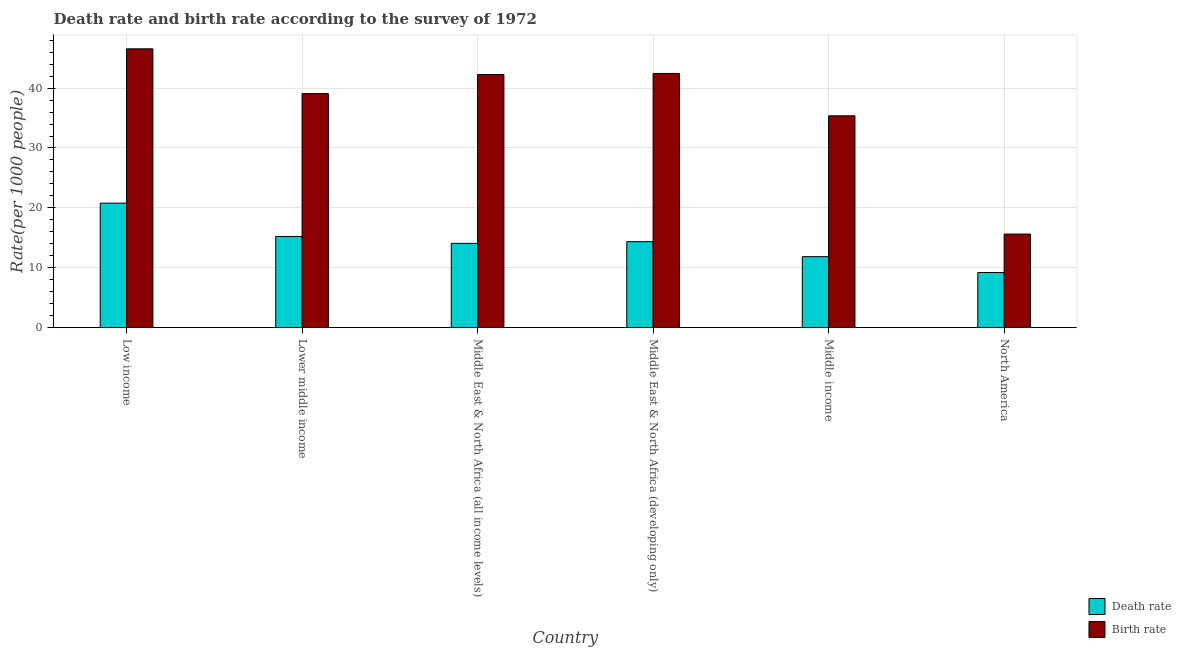How many different coloured bars are there?
Your response must be concise. 2. How many groups of bars are there?
Offer a terse response. 6. Are the number of bars per tick equal to the number of legend labels?
Ensure brevity in your answer.  Yes. How many bars are there on the 3rd tick from the left?
Ensure brevity in your answer.  2. What is the death rate in Lower middle income?
Your response must be concise. 15.23. Across all countries, what is the maximum birth rate?
Give a very brief answer. 46.56. Across all countries, what is the minimum birth rate?
Make the answer very short. 15.63. What is the total death rate in the graph?
Your response must be concise. 85.52. What is the difference between the birth rate in Middle East & North Africa (all income levels) and that in Middle East & North Africa (developing only)?
Provide a short and direct response. -0.18. What is the difference between the birth rate in North America and the death rate in Middle East & North Africa (all income levels)?
Provide a short and direct response. 1.55. What is the average birth rate per country?
Give a very brief answer. 36.89. What is the difference between the birth rate and death rate in Low income?
Keep it short and to the point. 25.76. In how many countries, is the death rate greater than 32 ?
Give a very brief answer. 0. What is the ratio of the death rate in Middle income to that in North America?
Provide a succinct answer. 1.29. Is the birth rate in Lower middle income less than that in North America?
Provide a short and direct response. No. What is the difference between the highest and the second highest death rate?
Provide a short and direct response. 5.57. What is the difference between the highest and the lowest birth rate?
Your answer should be very brief. 30.93. What does the 1st bar from the left in Middle income represents?
Ensure brevity in your answer.  Death rate. What does the 1st bar from the right in Middle East & North Africa (all income levels) represents?
Your response must be concise. Birth rate. How many countries are there in the graph?
Your response must be concise. 6. Are the values on the major ticks of Y-axis written in scientific E-notation?
Your answer should be very brief. No. Does the graph contain any zero values?
Provide a short and direct response. No. Does the graph contain grids?
Your answer should be compact. Yes. How many legend labels are there?
Provide a succinct answer. 2. How are the legend labels stacked?
Ensure brevity in your answer.  Vertical. What is the title of the graph?
Give a very brief answer. Death rate and birth rate according to the survey of 1972. Does "Ages 15-24" appear as one of the legend labels in the graph?
Provide a succinct answer. No. What is the label or title of the Y-axis?
Offer a very short reply. Rate(per 1000 people). What is the Rate(per 1000 people) in Death rate in Low income?
Give a very brief answer. 20.79. What is the Rate(per 1000 people) in Birth rate in Low income?
Ensure brevity in your answer.  46.56. What is the Rate(per 1000 people) in Death rate in Lower middle income?
Your response must be concise. 15.23. What is the Rate(per 1000 people) of Birth rate in Lower middle income?
Give a very brief answer. 39.08. What is the Rate(per 1000 people) of Death rate in Middle East & North Africa (all income levels)?
Make the answer very short. 14.08. What is the Rate(per 1000 people) of Birth rate in Middle East & North Africa (all income levels)?
Make the answer very short. 42.26. What is the Rate(per 1000 people) of Death rate in Middle East & North Africa (developing only)?
Your answer should be very brief. 14.36. What is the Rate(per 1000 people) of Birth rate in Middle East & North Africa (developing only)?
Ensure brevity in your answer.  42.44. What is the Rate(per 1000 people) in Death rate in Middle income?
Provide a succinct answer. 11.86. What is the Rate(per 1000 people) in Birth rate in Middle income?
Give a very brief answer. 35.37. What is the Rate(per 1000 people) of Death rate in North America?
Your answer should be very brief. 9.21. What is the Rate(per 1000 people) in Birth rate in North America?
Your answer should be very brief. 15.63. Across all countries, what is the maximum Rate(per 1000 people) of Death rate?
Offer a terse response. 20.79. Across all countries, what is the maximum Rate(per 1000 people) of Birth rate?
Offer a terse response. 46.56. Across all countries, what is the minimum Rate(per 1000 people) of Death rate?
Provide a short and direct response. 9.21. Across all countries, what is the minimum Rate(per 1000 people) in Birth rate?
Offer a terse response. 15.63. What is the total Rate(per 1000 people) of Death rate in the graph?
Keep it short and to the point. 85.52. What is the total Rate(per 1000 people) of Birth rate in the graph?
Offer a very short reply. 221.35. What is the difference between the Rate(per 1000 people) in Death rate in Low income and that in Lower middle income?
Provide a short and direct response. 5.57. What is the difference between the Rate(per 1000 people) in Birth rate in Low income and that in Lower middle income?
Offer a very short reply. 7.48. What is the difference between the Rate(per 1000 people) in Death rate in Low income and that in Middle East & North Africa (all income levels)?
Offer a very short reply. 6.72. What is the difference between the Rate(per 1000 people) in Birth rate in Low income and that in Middle East & North Africa (all income levels)?
Provide a succinct answer. 4.29. What is the difference between the Rate(per 1000 people) in Death rate in Low income and that in Middle East & North Africa (developing only)?
Offer a very short reply. 6.43. What is the difference between the Rate(per 1000 people) in Birth rate in Low income and that in Middle East & North Africa (developing only)?
Make the answer very short. 4.12. What is the difference between the Rate(per 1000 people) in Death rate in Low income and that in Middle income?
Keep it short and to the point. 8.94. What is the difference between the Rate(per 1000 people) in Birth rate in Low income and that in Middle income?
Make the answer very short. 11.18. What is the difference between the Rate(per 1000 people) in Death rate in Low income and that in North America?
Your answer should be very brief. 11.58. What is the difference between the Rate(per 1000 people) in Birth rate in Low income and that in North America?
Provide a short and direct response. 30.93. What is the difference between the Rate(per 1000 people) in Death rate in Lower middle income and that in Middle East & North Africa (all income levels)?
Provide a succinct answer. 1.15. What is the difference between the Rate(per 1000 people) in Birth rate in Lower middle income and that in Middle East & North Africa (all income levels)?
Offer a terse response. -3.18. What is the difference between the Rate(per 1000 people) of Death rate in Lower middle income and that in Middle East & North Africa (developing only)?
Give a very brief answer. 0.87. What is the difference between the Rate(per 1000 people) of Birth rate in Lower middle income and that in Middle East & North Africa (developing only)?
Keep it short and to the point. -3.36. What is the difference between the Rate(per 1000 people) in Death rate in Lower middle income and that in Middle income?
Your answer should be very brief. 3.37. What is the difference between the Rate(per 1000 people) of Birth rate in Lower middle income and that in Middle income?
Your response must be concise. 3.71. What is the difference between the Rate(per 1000 people) in Death rate in Lower middle income and that in North America?
Your answer should be very brief. 6.02. What is the difference between the Rate(per 1000 people) in Birth rate in Lower middle income and that in North America?
Provide a short and direct response. 23.45. What is the difference between the Rate(per 1000 people) of Death rate in Middle East & North Africa (all income levels) and that in Middle East & North Africa (developing only)?
Make the answer very short. -0.29. What is the difference between the Rate(per 1000 people) in Birth rate in Middle East & North Africa (all income levels) and that in Middle East & North Africa (developing only)?
Your answer should be compact. -0.18. What is the difference between the Rate(per 1000 people) of Death rate in Middle East & North Africa (all income levels) and that in Middle income?
Your response must be concise. 2.22. What is the difference between the Rate(per 1000 people) of Birth rate in Middle East & North Africa (all income levels) and that in Middle income?
Provide a short and direct response. 6.89. What is the difference between the Rate(per 1000 people) of Death rate in Middle East & North Africa (all income levels) and that in North America?
Keep it short and to the point. 4.87. What is the difference between the Rate(per 1000 people) in Birth rate in Middle East & North Africa (all income levels) and that in North America?
Your response must be concise. 26.63. What is the difference between the Rate(per 1000 people) in Death rate in Middle East & North Africa (developing only) and that in Middle income?
Your answer should be compact. 2.51. What is the difference between the Rate(per 1000 people) of Birth rate in Middle East & North Africa (developing only) and that in Middle income?
Provide a succinct answer. 7.07. What is the difference between the Rate(per 1000 people) of Death rate in Middle East & North Africa (developing only) and that in North America?
Give a very brief answer. 5.15. What is the difference between the Rate(per 1000 people) in Birth rate in Middle East & North Africa (developing only) and that in North America?
Make the answer very short. 26.81. What is the difference between the Rate(per 1000 people) in Death rate in Middle income and that in North America?
Your response must be concise. 2.65. What is the difference between the Rate(per 1000 people) in Birth rate in Middle income and that in North America?
Your response must be concise. 19.74. What is the difference between the Rate(per 1000 people) of Death rate in Low income and the Rate(per 1000 people) of Birth rate in Lower middle income?
Your response must be concise. -18.29. What is the difference between the Rate(per 1000 people) of Death rate in Low income and the Rate(per 1000 people) of Birth rate in Middle East & North Africa (all income levels)?
Offer a terse response. -21.47. What is the difference between the Rate(per 1000 people) in Death rate in Low income and the Rate(per 1000 people) in Birth rate in Middle East & North Africa (developing only)?
Ensure brevity in your answer.  -21.65. What is the difference between the Rate(per 1000 people) of Death rate in Low income and the Rate(per 1000 people) of Birth rate in Middle income?
Your answer should be compact. -14.58. What is the difference between the Rate(per 1000 people) in Death rate in Low income and the Rate(per 1000 people) in Birth rate in North America?
Give a very brief answer. 5.17. What is the difference between the Rate(per 1000 people) in Death rate in Lower middle income and the Rate(per 1000 people) in Birth rate in Middle East & North Africa (all income levels)?
Keep it short and to the point. -27.04. What is the difference between the Rate(per 1000 people) of Death rate in Lower middle income and the Rate(per 1000 people) of Birth rate in Middle East & North Africa (developing only)?
Your answer should be compact. -27.22. What is the difference between the Rate(per 1000 people) of Death rate in Lower middle income and the Rate(per 1000 people) of Birth rate in Middle income?
Keep it short and to the point. -20.15. What is the difference between the Rate(per 1000 people) of Death rate in Lower middle income and the Rate(per 1000 people) of Birth rate in North America?
Provide a short and direct response. -0.4. What is the difference between the Rate(per 1000 people) in Death rate in Middle East & North Africa (all income levels) and the Rate(per 1000 people) in Birth rate in Middle East & North Africa (developing only)?
Your answer should be very brief. -28.37. What is the difference between the Rate(per 1000 people) of Death rate in Middle East & North Africa (all income levels) and the Rate(per 1000 people) of Birth rate in Middle income?
Offer a terse response. -21.3. What is the difference between the Rate(per 1000 people) in Death rate in Middle East & North Africa (all income levels) and the Rate(per 1000 people) in Birth rate in North America?
Your response must be concise. -1.55. What is the difference between the Rate(per 1000 people) in Death rate in Middle East & North Africa (developing only) and the Rate(per 1000 people) in Birth rate in Middle income?
Provide a succinct answer. -21.01. What is the difference between the Rate(per 1000 people) of Death rate in Middle East & North Africa (developing only) and the Rate(per 1000 people) of Birth rate in North America?
Keep it short and to the point. -1.27. What is the difference between the Rate(per 1000 people) of Death rate in Middle income and the Rate(per 1000 people) of Birth rate in North America?
Keep it short and to the point. -3.77. What is the average Rate(per 1000 people) of Death rate per country?
Keep it short and to the point. 14.25. What is the average Rate(per 1000 people) in Birth rate per country?
Ensure brevity in your answer.  36.89. What is the difference between the Rate(per 1000 people) of Death rate and Rate(per 1000 people) of Birth rate in Low income?
Provide a succinct answer. -25.76. What is the difference between the Rate(per 1000 people) of Death rate and Rate(per 1000 people) of Birth rate in Lower middle income?
Make the answer very short. -23.85. What is the difference between the Rate(per 1000 people) in Death rate and Rate(per 1000 people) in Birth rate in Middle East & North Africa (all income levels)?
Ensure brevity in your answer.  -28.19. What is the difference between the Rate(per 1000 people) of Death rate and Rate(per 1000 people) of Birth rate in Middle East & North Africa (developing only)?
Ensure brevity in your answer.  -28.08. What is the difference between the Rate(per 1000 people) in Death rate and Rate(per 1000 people) in Birth rate in Middle income?
Provide a succinct answer. -23.52. What is the difference between the Rate(per 1000 people) in Death rate and Rate(per 1000 people) in Birth rate in North America?
Offer a very short reply. -6.42. What is the ratio of the Rate(per 1000 people) in Death rate in Low income to that in Lower middle income?
Provide a short and direct response. 1.37. What is the ratio of the Rate(per 1000 people) in Birth rate in Low income to that in Lower middle income?
Give a very brief answer. 1.19. What is the ratio of the Rate(per 1000 people) of Death rate in Low income to that in Middle East & North Africa (all income levels)?
Offer a terse response. 1.48. What is the ratio of the Rate(per 1000 people) of Birth rate in Low income to that in Middle East & North Africa (all income levels)?
Keep it short and to the point. 1.1. What is the ratio of the Rate(per 1000 people) of Death rate in Low income to that in Middle East & North Africa (developing only)?
Provide a short and direct response. 1.45. What is the ratio of the Rate(per 1000 people) of Birth rate in Low income to that in Middle East & North Africa (developing only)?
Offer a terse response. 1.1. What is the ratio of the Rate(per 1000 people) in Death rate in Low income to that in Middle income?
Ensure brevity in your answer.  1.75. What is the ratio of the Rate(per 1000 people) of Birth rate in Low income to that in Middle income?
Make the answer very short. 1.32. What is the ratio of the Rate(per 1000 people) in Death rate in Low income to that in North America?
Provide a short and direct response. 2.26. What is the ratio of the Rate(per 1000 people) of Birth rate in Low income to that in North America?
Provide a short and direct response. 2.98. What is the ratio of the Rate(per 1000 people) in Death rate in Lower middle income to that in Middle East & North Africa (all income levels)?
Your response must be concise. 1.08. What is the ratio of the Rate(per 1000 people) of Birth rate in Lower middle income to that in Middle East & North Africa (all income levels)?
Ensure brevity in your answer.  0.92. What is the ratio of the Rate(per 1000 people) of Death rate in Lower middle income to that in Middle East & North Africa (developing only)?
Your answer should be very brief. 1.06. What is the ratio of the Rate(per 1000 people) of Birth rate in Lower middle income to that in Middle East & North Africa (developing only)?
Your response must be concise. 0.92. What is the ratio of the Rate(per 1000 people) of Death rate in Lower middle income to that in Middle income?
Provide a short and direct response. 1.28. What is the ratio of the Rate(per 1000 people) of Birth rate in Lower middle income to that in Middle income?
Offer a terse response. 1.1. What is the ratio of the Rate(per 1000 people) of Death rate in Lower middle income to that in North America?
Ensure brevity in your answer.  1.65. What is the ratio of the Rate(per 1000 people) of Birth rate in Lower middle income to that in North America?
Your answer should be very brief. 2.5. What is the ratio of the Rate(per 1000 people) of Death rate in Middle East & North Africa (all income levels) to that in Middle East & North Africa (developing only)?
Keep it short and to the point. 0.98. What is the ratio of the Rate(per 1000 people) of Birth rate in Middle East & North Africa (all income levels) to that in Middle East & North Africa (developing only)?
Provide a succinct answer. 1. What is the ratio of the Rate(per 1000 people) of Death rate in Middle East & North Africa (all income levels) to that in Middle income?
Provide a short and direct response. 1.19. What is the ratio of the Rate(per 1000 people) of Birth rate in Middle East & North Africa (all income levels) to that in Middle income?
Offer a terse response. 1.19. What is the ratio of the Rate(per 1000 people) of Death rate in Middle East & North Africa (all income levels) to that in North America?
Keep it short and to the point. 1.53. What is the ratio of the Rate(per 1000 people) of Birth rate in Middle East & North Africa (all income levels) to that in North America?
Ensure brevity in your answer.  2.7. What is the ratio of the Rate(per 1000 people) in Death rate in Middle East & North Africa (developing only) to that in Middle income?
Your answer should be very brief. 1.21. What is the ratio of the Rate(per 1000 people) in Birth rate in Middle East & North Africa (developing only) to that in Middle income?
Your response must be concise. 1.2. What is the ratio of the Rate(per 1000 people) in Death rate in Middle East & North Africa (developing only) to that in North America?
Your answer should be very brief. 1.56. What is the ratio of the Rate(per 1000 people) of Birth rate in Middle East & North Africa (developing only) to that in North America?
Provide a short and direct response. 2.72. What is the ratio of the Rate(per 1000 people) in Death rate in Middle income to that in North America?
Provide a succinct answer. 1.29. What is the ratio of the Rate(per 1000 people) of Birth rate in Middle income to that in North America?
Provide a short and direct response. 2.26. What is the difference between the highest and the second highest Rate(per 1000 people) of Death rate?
Give a very brief answer. 5.57. What is the difference between the highest and the second highest Rate(per 1000 people) in Birth rate?
Offer a very short reply. 4.12. What is the difference between the highest and the lowest Rate(per 1000 people) of Death rate?
Offer a terse response. 11.58. What is the difference between the highest and the lowest Rate(per 1000 people) in Birth rate?
Your response must be concise. 30.93. 